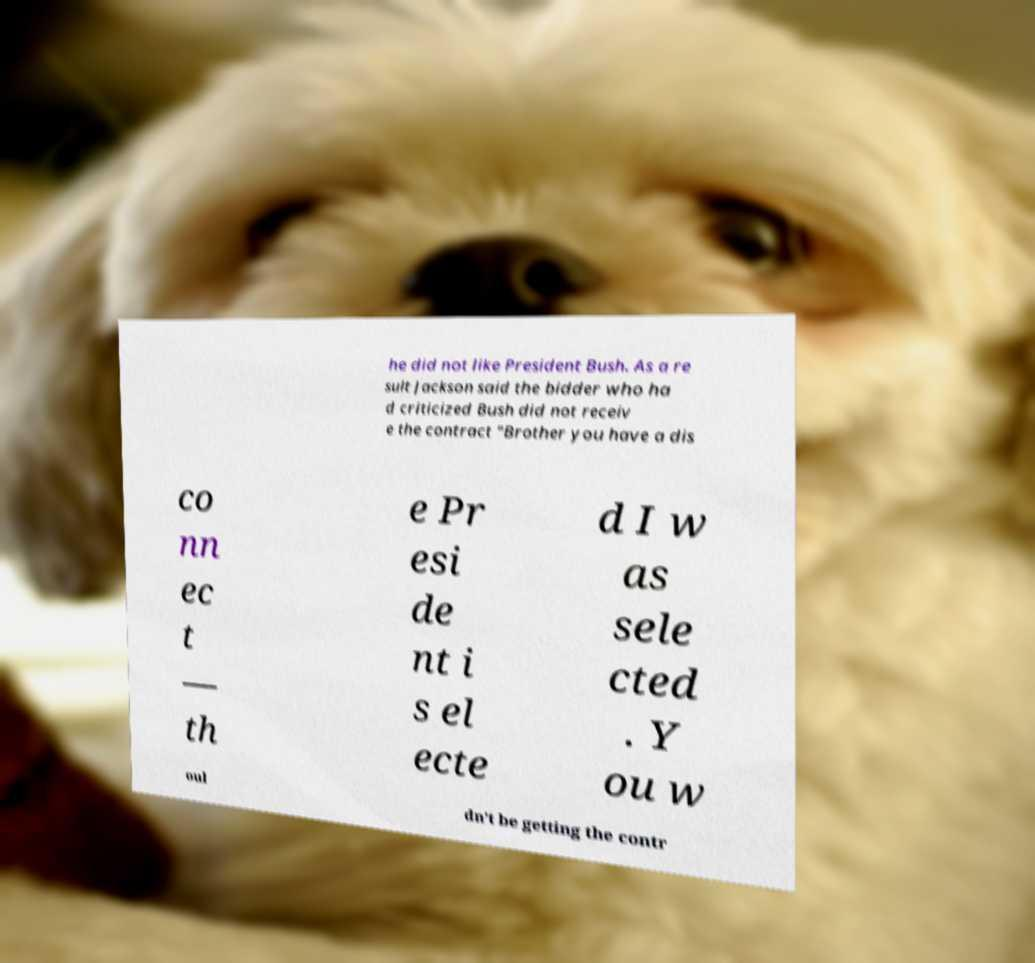Can you read and provide the text displayed in the image?This photo seems to have some interesting text. Can you extract and type it out for me? he did not like President Bush. As a re sult Jackson said the bidder who ha d criticized Bush did not receiv e the contract "Brother you have a dis co nn ec t — th e Pr esi de nt i s el ecte d I w as sele cted . Y ou w oul dn’t be getting the contr 